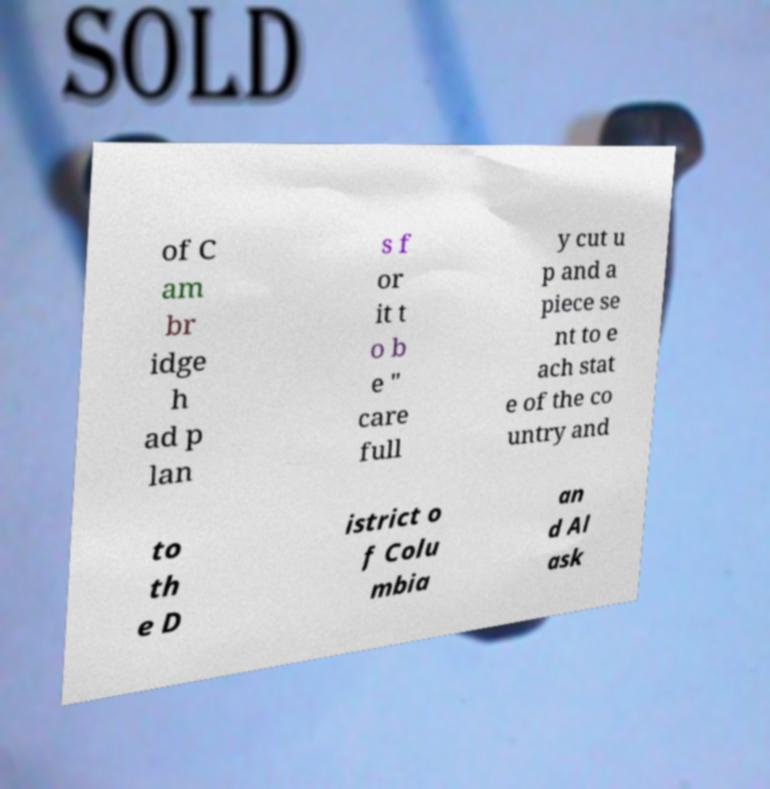Please read and relay the text visible in this image. What does it say? of C am br idge h ad p lan s f or it t o b e " care full y cut u p and a piece se nt to e ach stat e of the co untry and to th e D istrict o f Colu mbia an d Al ask 